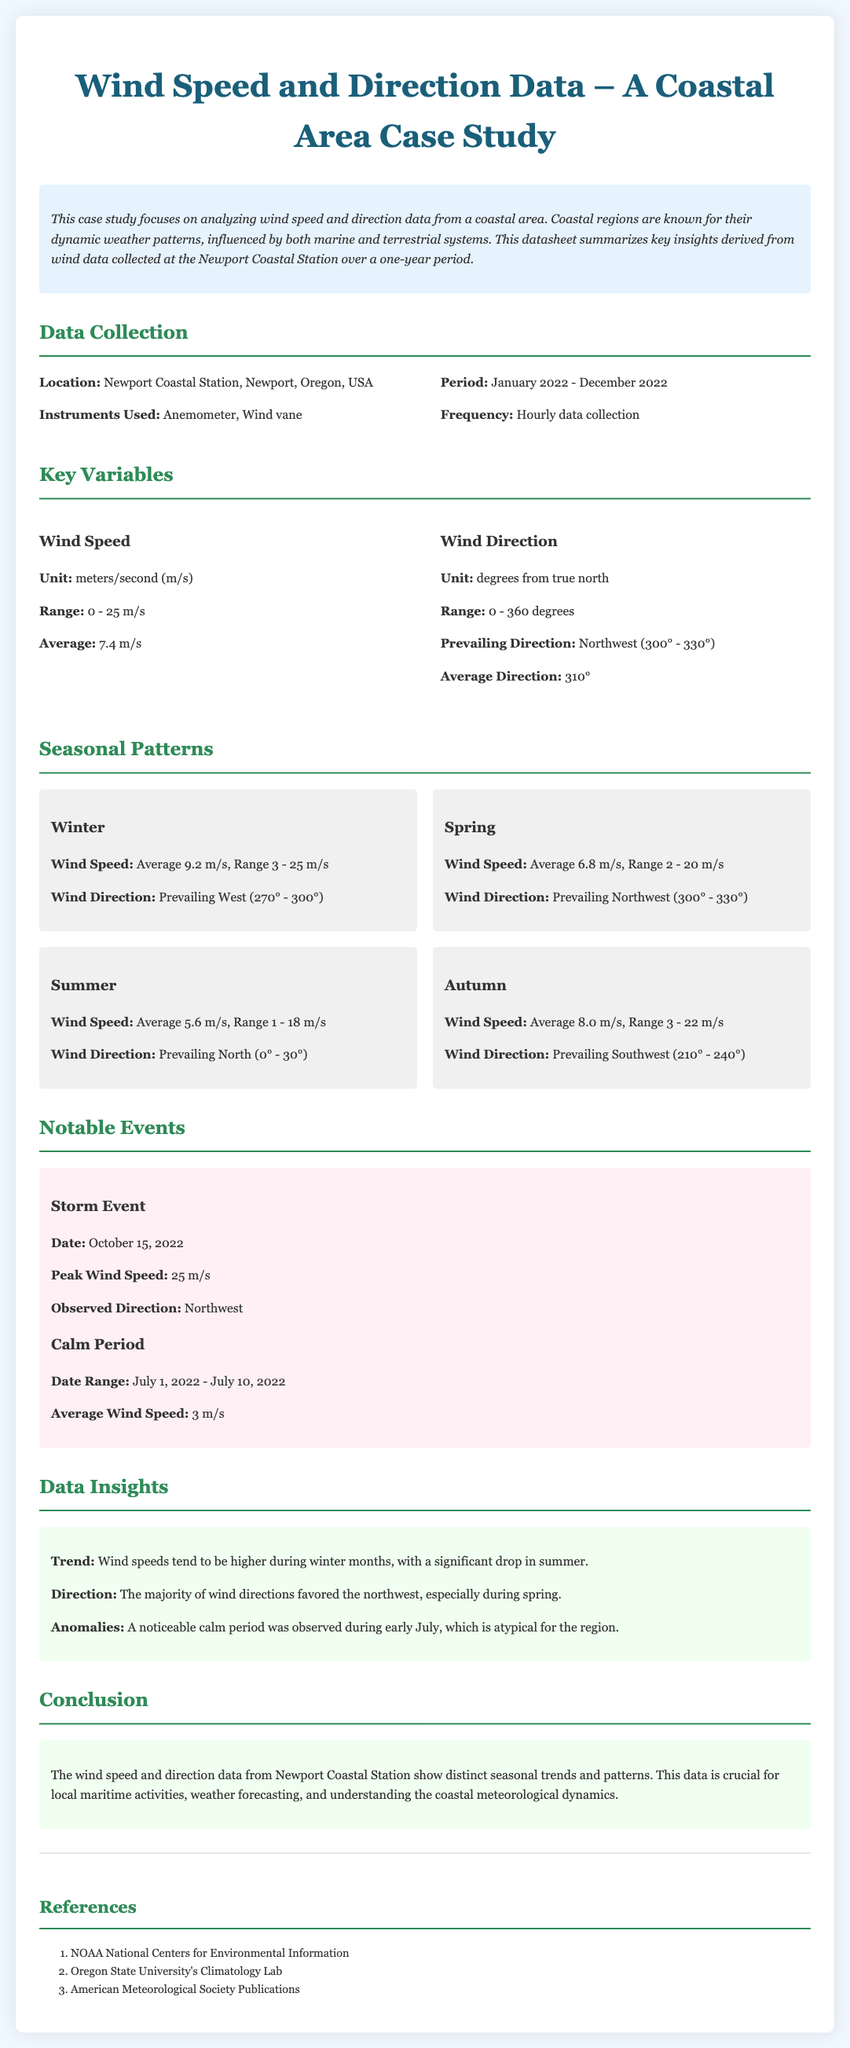What is the location of the study? The document states that the data was collected from Newport Coastal Station, Newport, Oregon, USA.
Answer: Newport Coastal Station, Newport, Oregon, USA What was the average wind speed recorded? According to the key variables section, the average wind speed was given as 7.4 m/s.
Answer: 7.4 m/s What is the unit of wind direction? The document specifies that the unit for wind direction is degrees from true north.
Answer: degrees from true north Which season had the highest average wind speed? The seasonal patterns section indicates that winter had the highest average wind speed of 9.2 m/s.
Answer: Winter What was the peak wind speed during the notable storm event? The notable events section mentions that the peak wind speed recorded during the storm was 25 m/s.
Answer: 25 m/s What direction did most winds come from in spring? The document notes that the prevailing wind direction in spring was Northwest, specifically between 300° - 330°.
Answer: Northwest What was the duration of the calm period noted in the document? The document indicates that the calm period lasted from July 1, 2022, to July 10, 2022.
Answer: July 1, 2022 - July 10, 2022 How often was the data collected? The data collection frequency mentioned in the document is hourly.
Answer: Hourly What is one of the references listed in the document? The references section includes the NOAA National Centers for Environmental Information as one of the sources.
Answer: NOAA National Centers for Environmental Information 